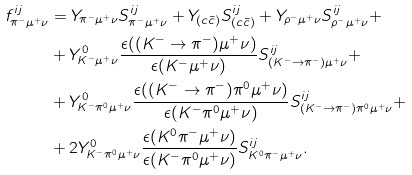Convert formula to latex. <formula><loc_0><loc_0><loc_500><loc_500>f _ { \pi ^ { - } \mu ^ { + } \nu } ^ { i j } & = Y _ { \pi ^ { - } \mu ^ { + } \nu } S _ { \pi ^ { - } \mu ^ { + } \nu } ^ { i j } + Y _ { ( c \bar { c } ) } S _ { ( c \bar { c } ) } ^ { i j } + Y _ { \rho ^ { - } \mu ^ { + } \nu } S _ { \rho ^ { - } \mu ^ { + } \nu } ^ { i j } + \\ & + Y ^ { 0 } _ { K ^ { - } \mu ^ { + } \nu } \frac { \epsilon ( ( K ^ { - } \rightarrow \pi ^ { - } ) \mu ^ { + } \nu ) } { \epsilon ( K ^ { - } \mu ^ { + } \nu ) } S _ { ( K ^ { - } \rightarrow \pi ^ { - } ) \mu ^ { + } \nu } ^ { i j } + \\ & + Y ^ { 0 } _ { K ^ { - } \pi ^ { 0 } \mu ^ { + } \nu } \frac { \epsilon ( ( K ^ { - } \rightarrow \pi ^ { - } ) \pi ^ { 0 } \mu ^ { + } \nu ) } { \epsilon ( K ^ { - } \pi ^ { 0 } \mu ^ { + } \nu ) } S _ { ( K ^ { - } \rightarrow \pi ^ { - } ) \pi ^ { 0 } \mu ^ { + } \nu } ^ { i j } + \\ & + 2 Y ^ { 0 } _ { K ^ { - } \pi ^ { 0 } \mu ^ { + } \nu } \frac { \epsilon ( K ^ { 0 } \pi ^ { - } \mu ^ { + } \nu ) } { \epsilon ( K ^ { - } \pi ^ { 0 } \mu ^ { + } \nu ) } S _ { K ^ { 0 } \pi ^ { - } \mu ^ { + } \nu } ^ { i j } .</formula> 